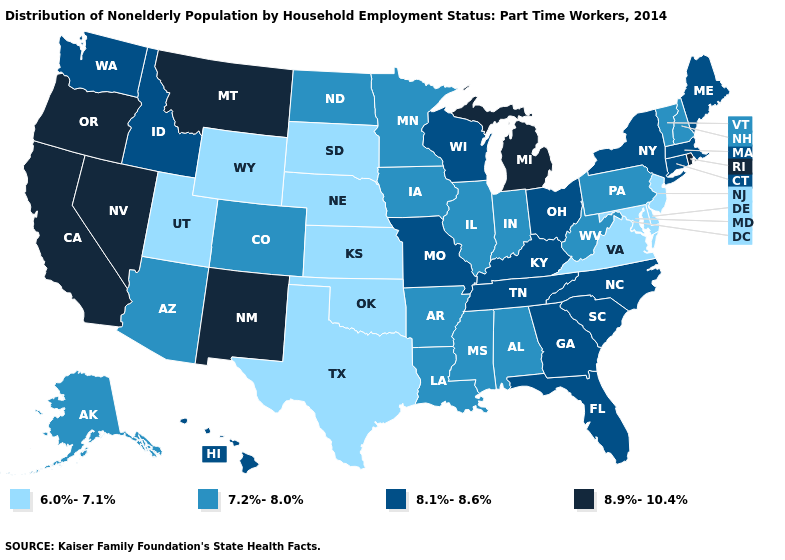Name the states that have a value in the range 6.0%-7.1%?
Answer briefly. Delaware, Kansas, Maryland, Nebraska, New Jersey, Oklahoma, South Dakota, Texas, Utah, Virginia, Wyoming. Name the states that have a value in the range 7.2%-8.0%?
Short answer required. Alabama, Alaska, Arizona, Arkansas, Colorado, Illinois, Indiana, Iowa, Louisiana, Minnesota, Mississippi, New Hampshire, North Dakota, Pennsylvania, Vermont, West Virginia. Does Kentucky have the highest value in the USA?
Give a very brief answer. No. What is the highest value in the USA?
Quick response, please. 8.9%-10.4%. Does California have the highest value in the USA?
Write a very short answer. Yes. Which states have the lowest value in the USA?
Quick response, please. Delaware, Kansas, Maryland, Nebraska, New Jersey, Oklahoma, South Dakota, Texas, Utah, Virginia, Wyoming. Which states hav the highest value in the MidWest?
Be succinct. Michigan. What is the value of Virginia?
Keep it brief. 6.0%-7.1%. Name the states that have a value in the range 8.1%-8.6%?
Give a very brief answer. Connecticut, Florida, Georgia, Hawaii, Idaho, Kentucky, Maine, Massachusetts, Missouri, New York, North Carolina, Ohio, South Carolina, Tennessee, Washington, Wisconsin. What is the value of Illinois?
Give a very brief answer. 7.2%-8.0%. What is the lowest value in the MidWest?
Answer briefly. 6.0%-7.1%. Name the states that have a value in the range 8.1%-8.6%?
Keep it brief. Connecticut, Florida, Georgia, Hawaii, Idaho, Kentucky, Maine, Massachusetts, Missouri, New York, North Carolina, Ohio, South Carolina, Tennessee, Washington, Wisconsin. Name the states that have a value in the range 8.9%-10.4%?
Be succinct. California, Michigan, Montana, Nevada, New Mexico, Oregon, Rhode Island. What is the value of Montana?
Answer briefly. 8.9%-10.4%. Which states have the highest value in the USA?
Give a very brief answer. California, Michigan, Montana, Nevada, New Mexico, Oregon, Rhode Island. 